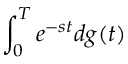Convert formula to latex. <formula><loc_0><loc_0><loc_500><loc_500>\int _ { 0 } ^ { T } e ^ { - s t } d g ( t )</formula> 